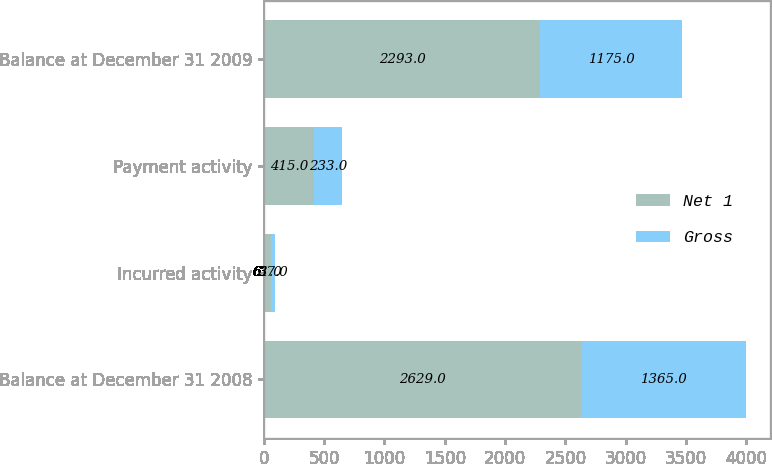Convert chart to OTSL. <chart><loc_0><loc_0><loc_500><loc_500><stacked_bar_chart><ecel><fcel>Balance at December 31 2008<fcel>Incurred activity<fcel>Payment activity<fcel>Balance at December 31 2009<nl><fcel>Net 1<fcel>2629<fcel>61<fcel>415<fcel>2293<nl><fcel>Gross<fcel>1365<fcel>37<fcel>233<fcel>1175<nl></chart> 